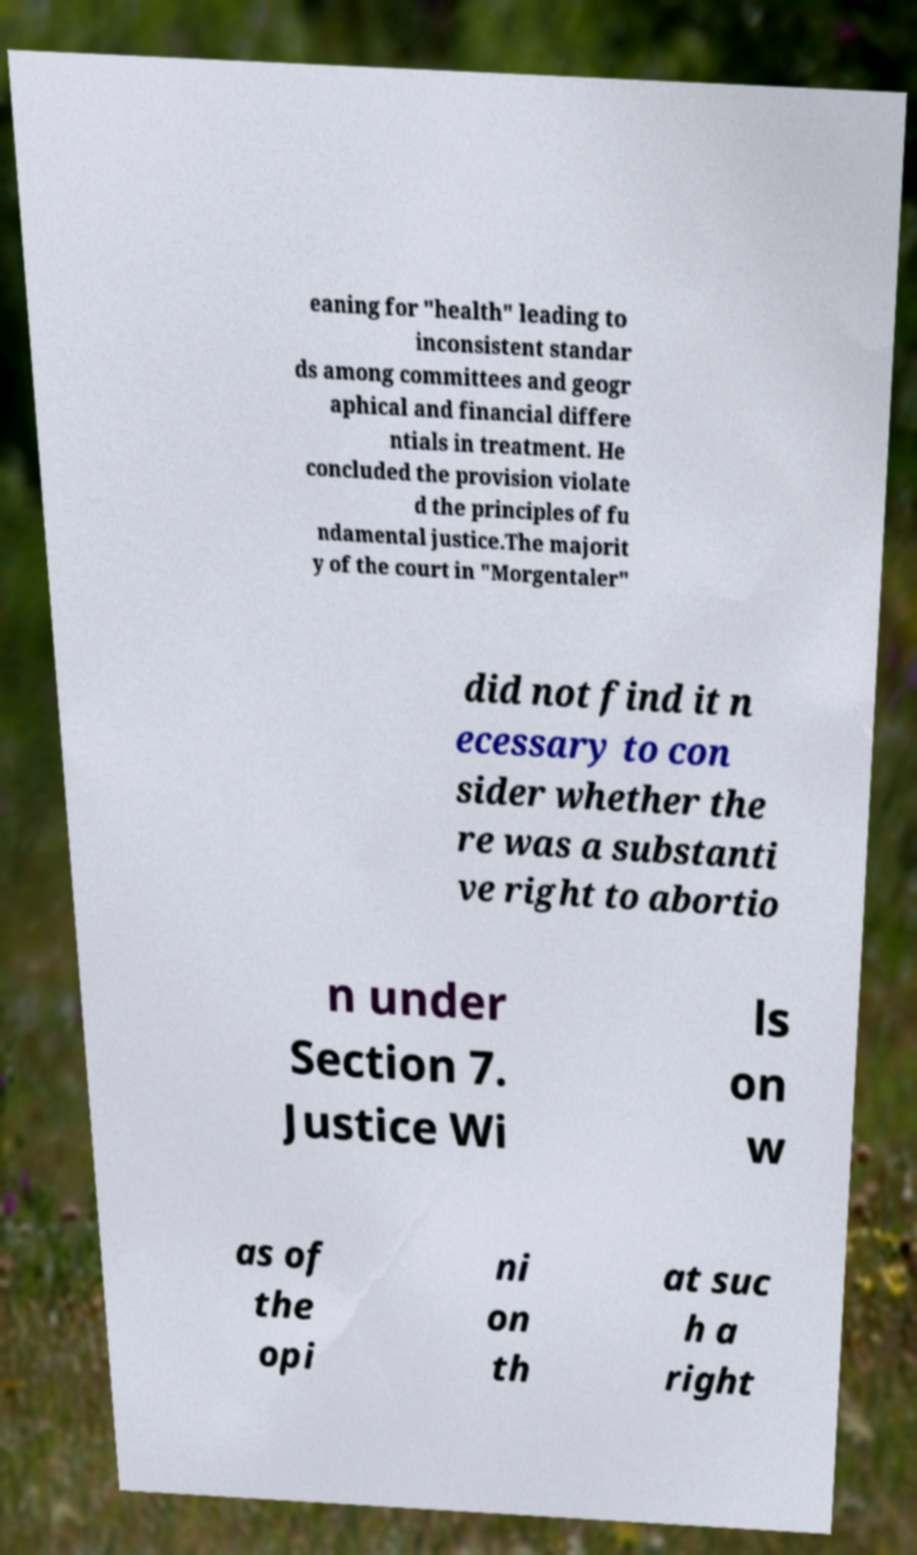There's text embedded in this image that I need extracted. Can you transcribe it verbatim? eaning for "health" leading to inconsistent standar ds among committees and geogr aphical and financial differe ntials in treatment. He concluded the provision violate d the principles of fu ndamental justice.The majorit y of the court in "Morgentaler" did not find it n ecessary to con sider whether the re was a substanti ve right to abortio n under Section 7. Justice Wi ls on w as of the opi ni on th at suc h a right 